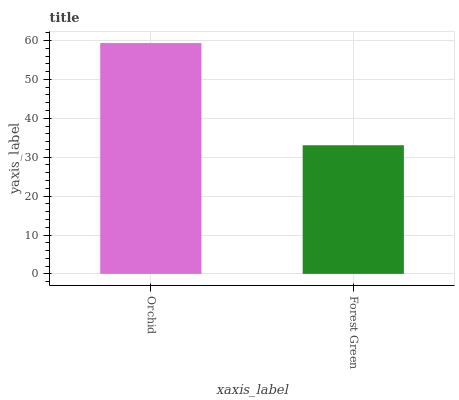Is Forest Green the minimum?
Answer yes or no. Yes. Is Orchid the maximum?
Answer yes or no. Yes. Is Forest Green the maximum?
Answer yes or no. No. Is Orchid greater than Forest Green?
Answer yes or no. Yes. Is Forest Green less than Orchid?
Answer yes or no. Yes. Is Forest Green greater than Orchid?
Answer yes or no. No. Is Orchid less than Forest Green?
Answer yes or no. No. Is Orchid the high median?
Answer yes or no. Yes. Is Forest Green the low median?
Answer yes or no. Yes. Is Forest Green the high median?
Answer yes or no. No. Is Orchid the low median?
Answer yes or no. No. 